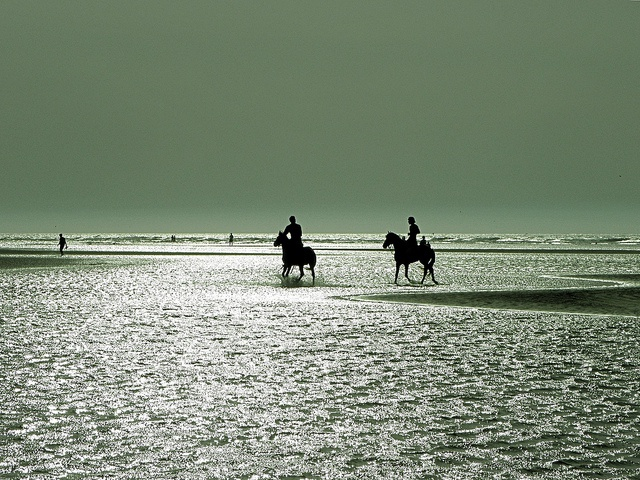Describe the objects in this image and their specific colors. I can see horse in gray, black, darkgray, and lightgray tones, horse in gray, black, lightgray, and darkgray tones, people in gray, black, darkgray, and lightgray tones, people in gray, black, darkgray, and beige tones, and people in gray, black, and darkgray tones in this image. 